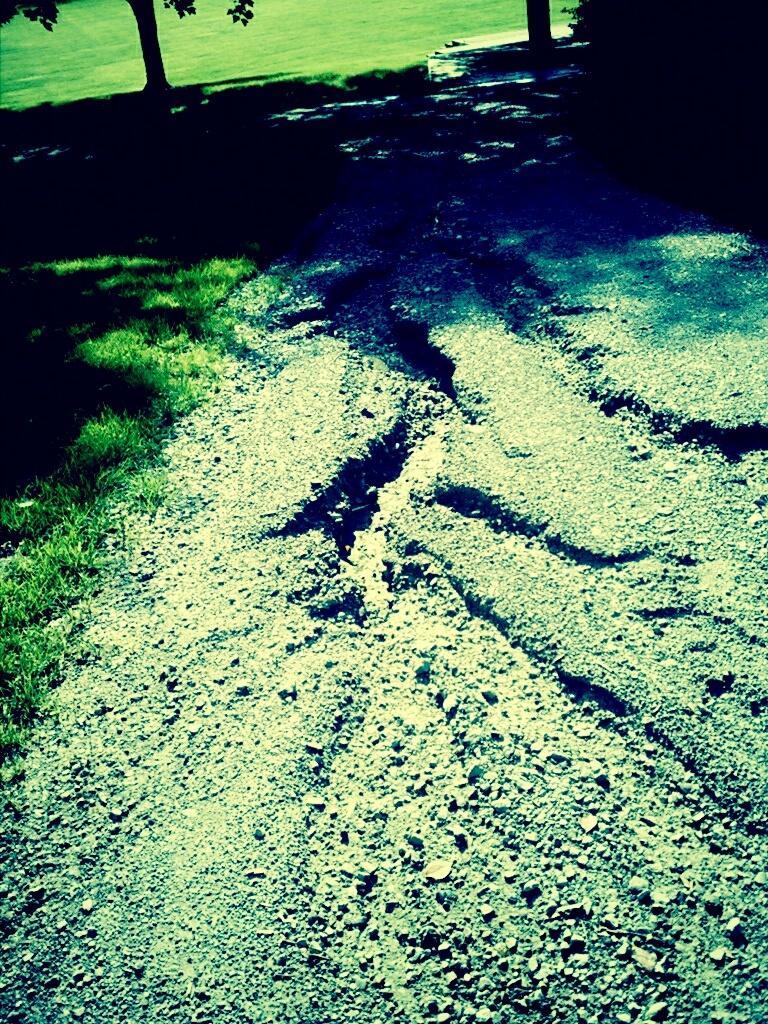Can you describe this image briefly? In the picture we can see a path which is cracked and beside it, we can see grass surface and in the background also we can see a grass surface with two trees. 